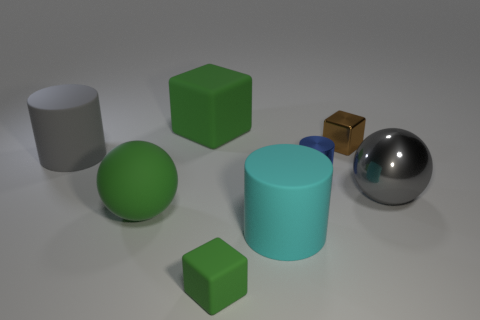Subtract all metal blocks. How many blocks are left? 2 Subtract all gray balls. How many green cubes are left? 2 Subtract 1 cylinders. How many cylinders are left? 2 Subtract all yellow cylinders. Subtract all green spheres. How many cylinders are left? 3 Add 1 gray objects. How many objects exist? 9 Subtract all cylinders. How many objects are left? 5 Add 8 tiny blue metallic objects. How many tiny blue metallic objects exist? 9 Subtract 0 red cubes. How many objects are left? 8 Subtract all small brown things. Subtract all large blocks. How many objects are left? 6 Add 8 cyan rubber cylinders. How many cyan rubber cylinders are left? 9 